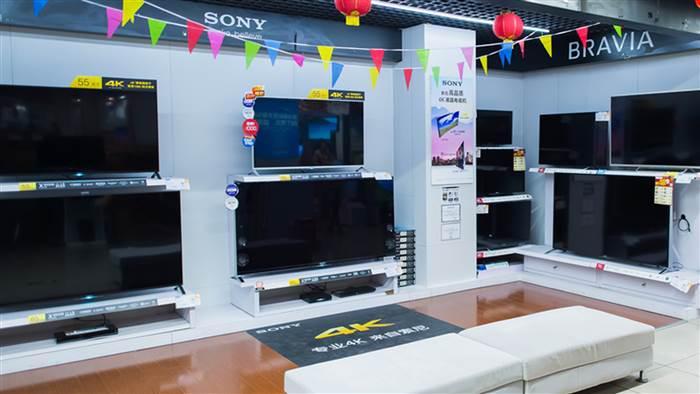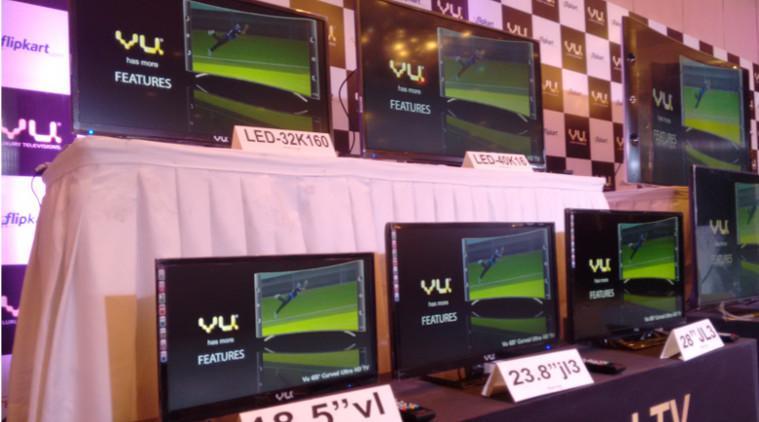The first image is the image on the left, the second image is the image on the right. Evaluate the accuracy of this statement regarding the images: "A single person is shown with some televisions.". Is it true? Answer yes or no. No. The first image is the image on the left, the second image is the image on the right. Examine the images to the left and right. Is the description "An image shows at least one man standing by a screen display." accurate? Answer yes or no. No. 